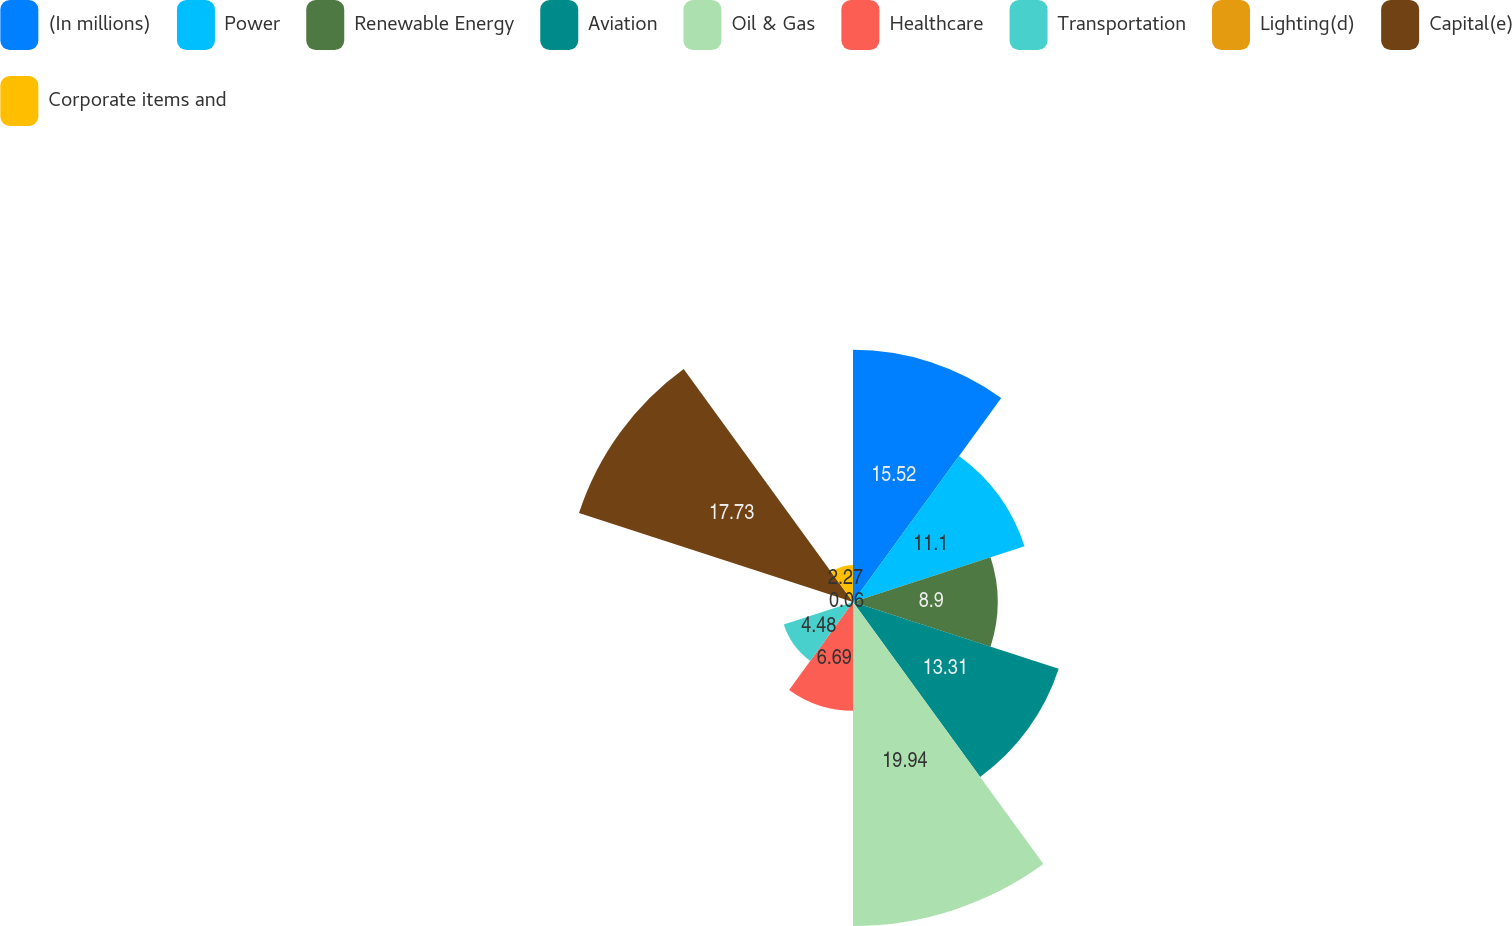<chart> <loc_0><loc_0><loc_500><loc_500><pie_chart><fcel>(In millions)<fcel>Power<fcel>Renewable Energy<fcel>Aviation<fcel>Oil & Gas<fcel>Healthcare<fcel>Transportation<fcel>Lighting(d)<fcel>Capital(e)<fcel>Corporate items and<nl><fcel>15.52%<fcel>11.1%<fcel>8.9%<fcel>13.31%<fcel>19.94%<fcel>6.69%<fcel>4.48%<fcel>0.06%<fcel>17.73%<fcel>2.27%<nl></chart> 